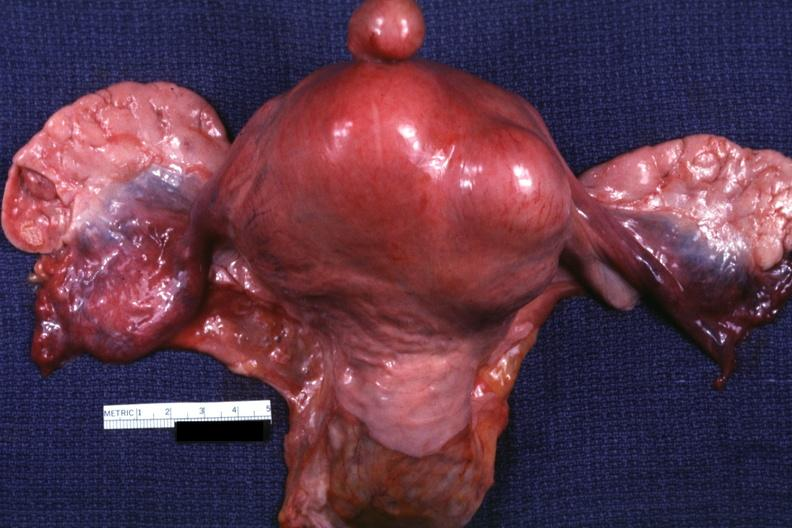what is a good example one pedunculated myoma?
Answer the question using a single word or phrase. This 